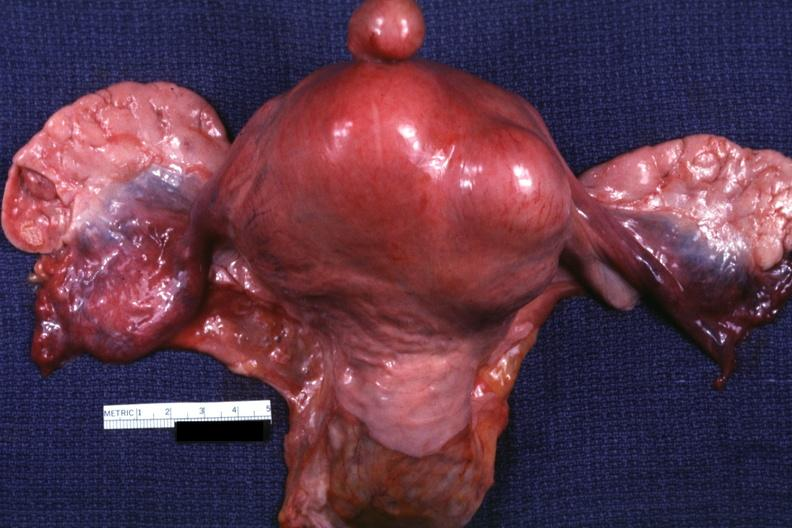what is a good example one pedunculated myoma?
Answer the question using a single word or phrase. This 